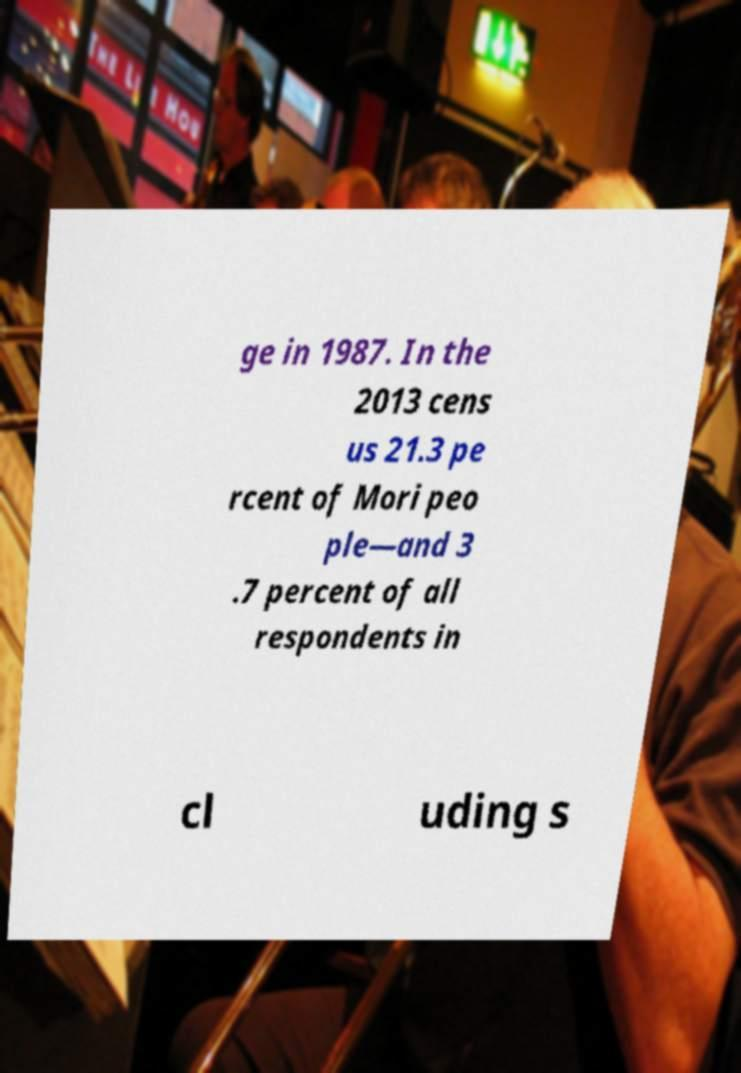Can you accurately transcribe the text from the provided image for me? ge in 1987. In the 2013 cens us 21.3 pe rcent of Mori peo ple—and 3 .7 percent of all respondents in cl uding s 